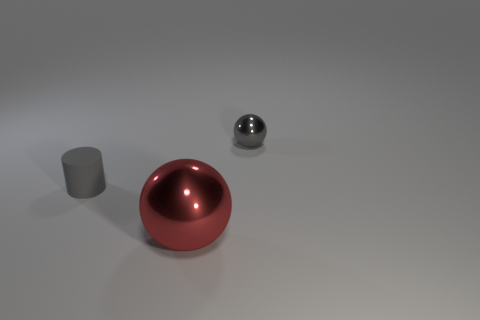Add 3 large red metal objects. How many objects exist? 6 Subtract all cylinders. How many objects are left? 2 Add 1 small metallic things. How many small metallic things are left? 2 Add 3 metallic spheres. How many metallic spheres exist? 5 Subtract 1 red balls. How many objects are left? 2 Subtract all tiny gray cylinders. Subtract all tiny gray matte cylinders. How many objects are left? 1 